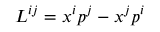<formula> <loc_0><loc_0><loc_500><loc_500>L ^ { i j } = x ^ { i } p ^ { j } - x ^ { j } p ^ { i }</formula> 